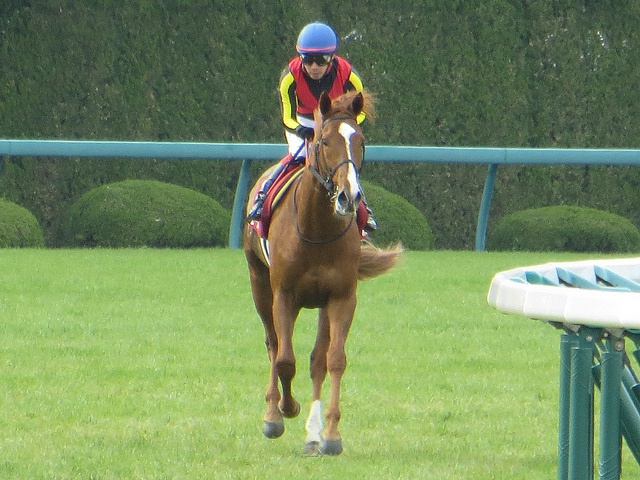Describe the objects in this image and their specific colors. I can see horse in black and gray tones and people in black, gray, brown, and lightblue tones in this image. 